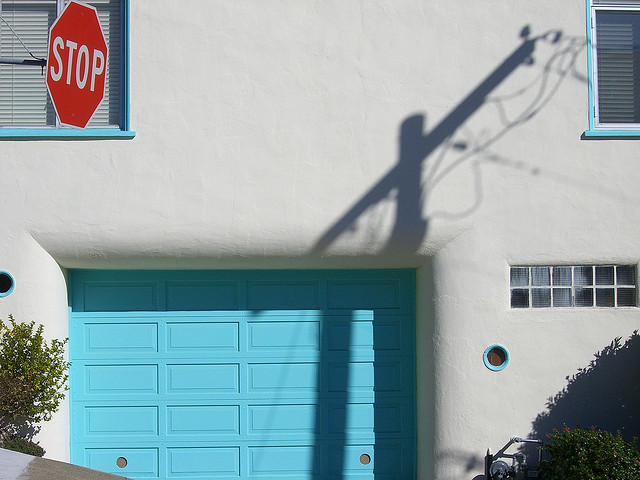Read all the text in this image. STOP 